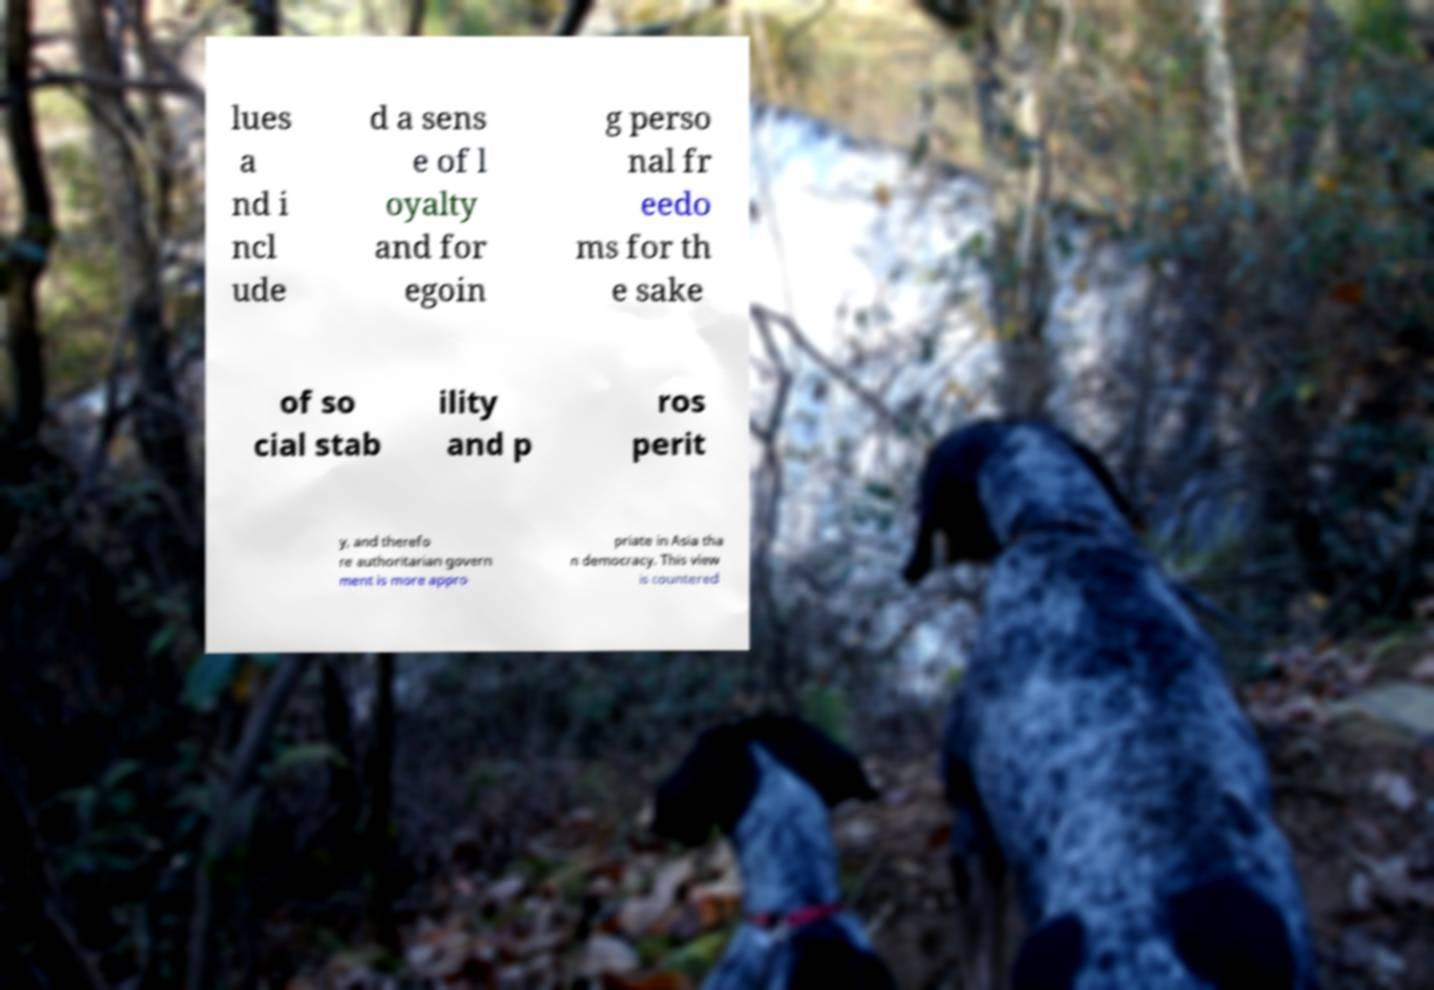Could you assist in decoding the text presented in this image and type it out clearly? lues a nd i ncl ude d a sens e of l oyalty and for egoin g perso nal fr eedo ms for th e sake of so cial stab ility and p ros perit y, and therefo re authoritarian govern ment is more appro priate in Asia tha n democracy. This view is countered 